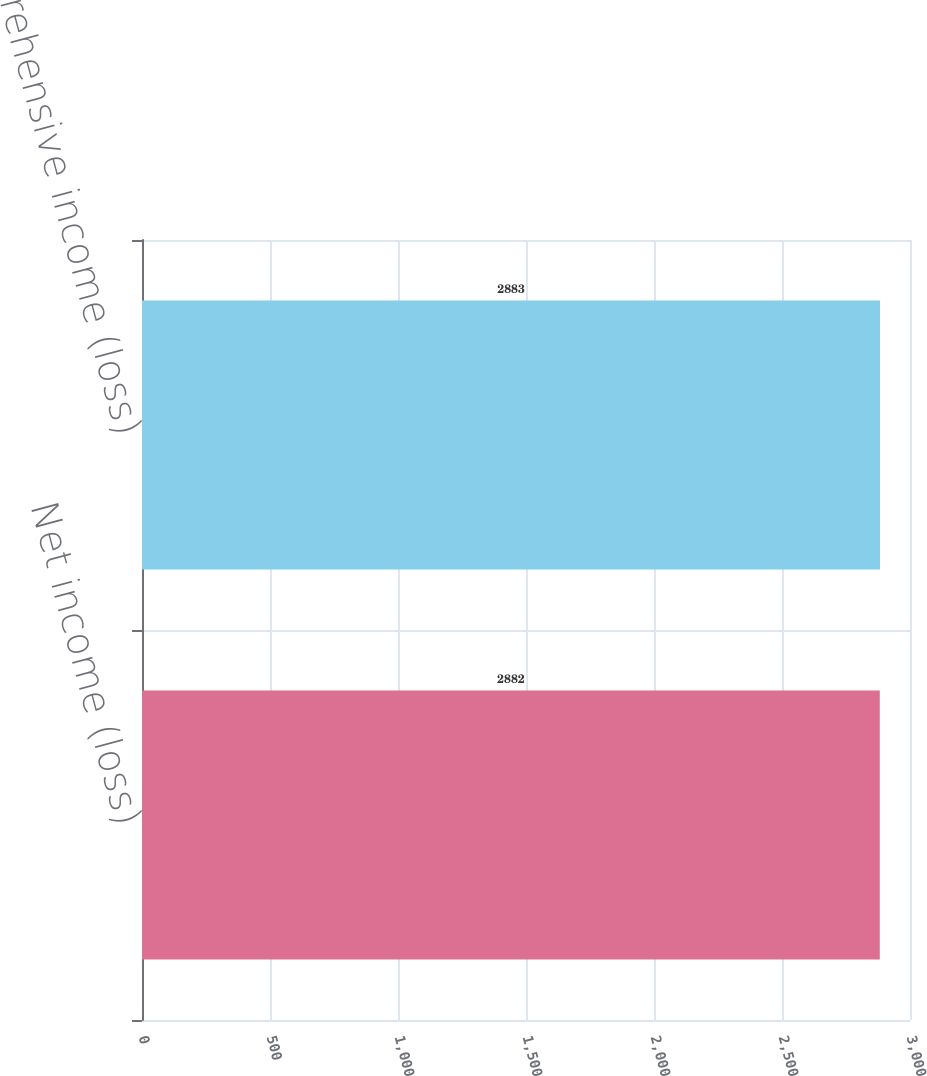Convert chart. <chart><loc_0><loc_0><loc_500><loc_500><bar_chart><fcel>Net income (loss)<fcel>Comprehensive income (loss)<nl><fcel>2882<fcel>2883<nl></chart> 